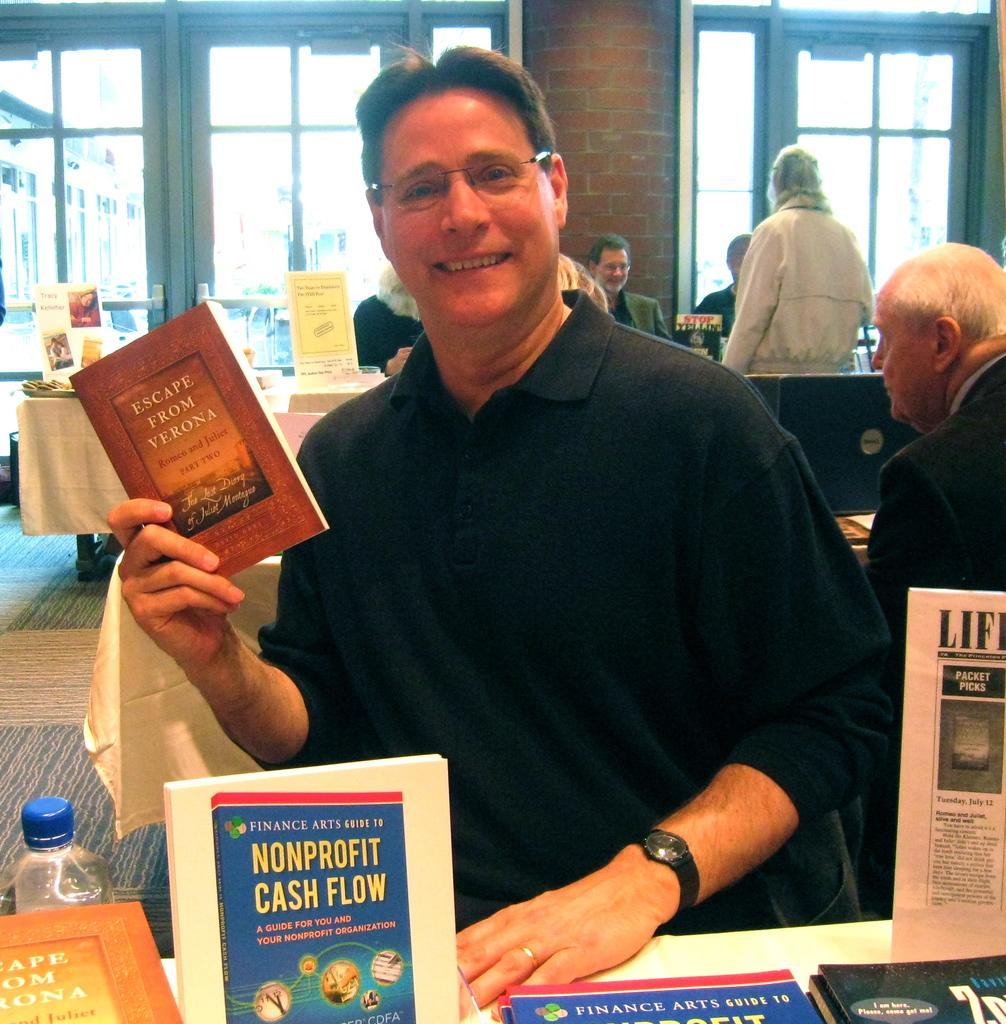<image>
Give a short and clear explanation of the subsequent image. A man is holding a copy of the book Escape From Verona by David Gray 